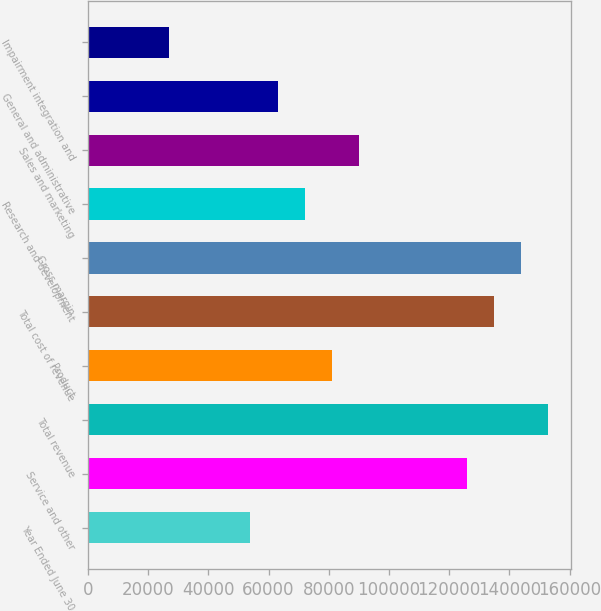<chart> <loc_0><loc_0><loc_500><loc_500><bar_chart><fcel>Year Ended June 30<fcel>Service and other<fcel>Total revenue<fcel>Product<fcel>Total cost of revenue<fcel>Gross margin<fcel>Research and development<fcel>Sales and marketing<fcel>General and administrative<fcel>Impairment integration and<nl><fcel>53970.6<fcel>125929<fcel>152914<fcel>80955.1<fcel>134924<fcel>143919<fcel>71960.3<fcel>89950<fcel>62965.4<fcel>26986.1<nl></chart> 